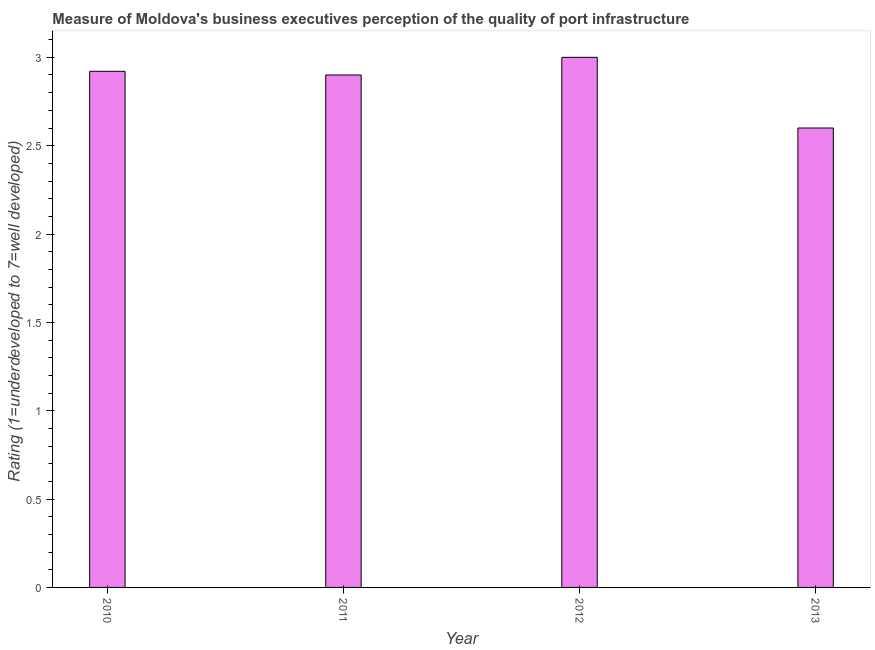Does the graph contain grids?
Your response must be concise. No. What is the title of the graph?
Your response must be concise. Measure of Moldova's business executives perception of the quality of port infrastructure. What is the label or title of the Y-axis?
Provide a succinct answer. Rating (1=underdeveloped to 7=well developed) . Across all years, what is the maximum rating measuring quality of port infrastructure?
Your response must be concise. 3. In which year was the rating measuring quality of port infrastructure maximum?
Ensure brevity in your answer.  2012. What is the sum of the rating measuring quality of port infrastructure?
Offer a terse response. 11.42. What is the difference between the rating measuring quality of port infrastructure in 2010 and 2011?
Keep it short and to the point. 0.02. What is the average rating measuring quality of port infrastructure per year?
Make the answer very short. 2.85. What is the median rating measuring quality of port infrastructure?
Offer a very short reply. 2.91. What is the ratio of the rating measuring quality of port infrastructure in 2010 to that in 2012?
Provide a short and direct response. 0.97. Is the difference between the rating measuring quality of port infrastructure in 2011 and 2012 greater than the difference between any two years?
Give a very brief answer. No. What is the difference between the highest and the second highest rating measuring quality of port infrastructure?
Give a very brief answer. 0.08. How many bars are there?
Offer a terse response. 4. What is the difference between two consecutive major ticks on the Y-axis?
Give a very brief answer. 0.5. What is the Rating (1=underdeveloped to 7=well developed)  of 2010?
Offer a very short reply. 2.92. What is the Rating (1=underdeveloped to 7=well developed)  in 2012?
Your answer should be very brief. 3. What is the Rating (1=underdeveloped to 7=well developed)  of 2013?
Offer a very short reply. 2.6. What is the difference between the Rating (1=underdeveloped to 7=well developed)  in 2010 and 2011?
Provide a succinct answer. 0.02. What is the difference between the Rating (1=underdeveloped to 7=well developed)  in 2010 and 2012?
Keep it short and to the point. -0.08. What is the difference between the Rating (1=underdeveloped to 7=well developed)  in 2010 and 2013?
Provide a succinct answer. 0.32. What is the difference between the Rating (1=underdeveloped to 7=well developed)  in 2011 and 2013?
Give a very brief answer. 0.3. What is the ratio of the Rating (1=underdeveloped to 7=well developed)  in 2010 to that in 2013?
Your answer should be compact. 1.12. What is the ratio of the Rating (1=underdeveloped to 7=well developed)  in 2011 to that in 2012?
Provide a short and direct response. 0.97. What is the ratio of the Rating (1=underdeveloped to 7=well developed)  in 2011 to that in 2013?
Offer a very short reply. 1.11. What is the ratio of the Rating (1=underdeveloped to 7=well developed)  in 2012 to that in 2013?
Your response must be concise. 1.15. 